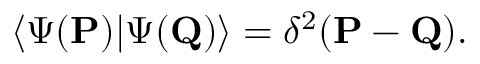<formula> <loc_0><loc_0><loc_500><loc_500>\langle \Psi ( { P } ) | \Psi ( { Q } ) \rangle = \delta ^ { 2 } ( { P } - { Q } ) .</formula> 